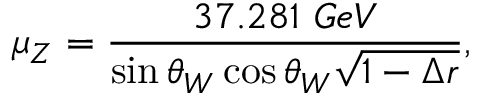Convert formula to latex. <formula><loc_0><loc_0><loc_500><loc_500>\mu _ { Z } = { \frac { 3 7 . 2 8 1 G e V } { \sin \theta _ { W } \cos \theta _ { W } \sqrt { 1 - \Delta r } } } ,</formula> 